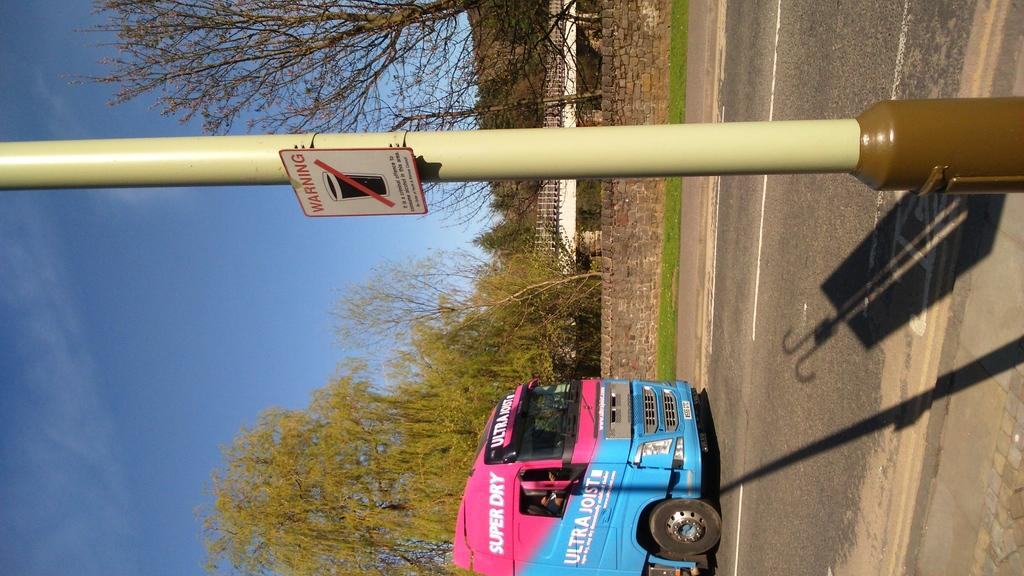<image>
Share a concise interpretation of the image provided. Pink and blue bus that says "Super Dry" next to a yellow pole. 